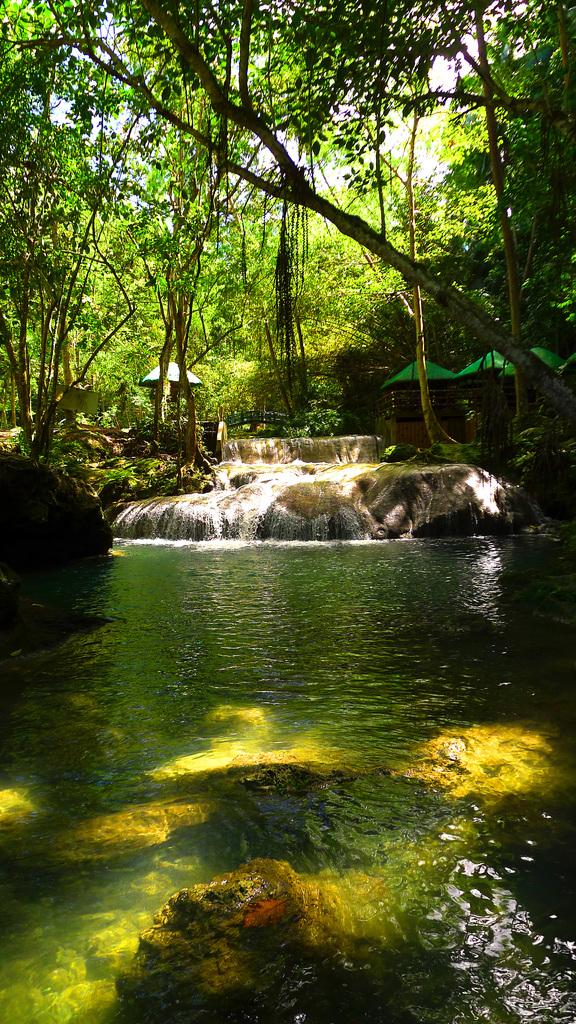What type of natural environment is shown in the image? The image depicts a forest area. What are some of the features of the forest area? There are trees, rocks, and a waterfall in the image. Are there any man-made structures in the image? Yes, there are railings in the image. What is the source of water in the image? The waterfall is the source of water in the image. Can you describe the water in the image? There is water visible in the image. How many cherries can be seen hanging from the trees in the image? There are no cherries visible in the image; it depicts a forest area with trees, rocks, a waterfall, and railings. Can you hear the bell ringing in the image? There is no bell present in the image, so it cannot be heard. 